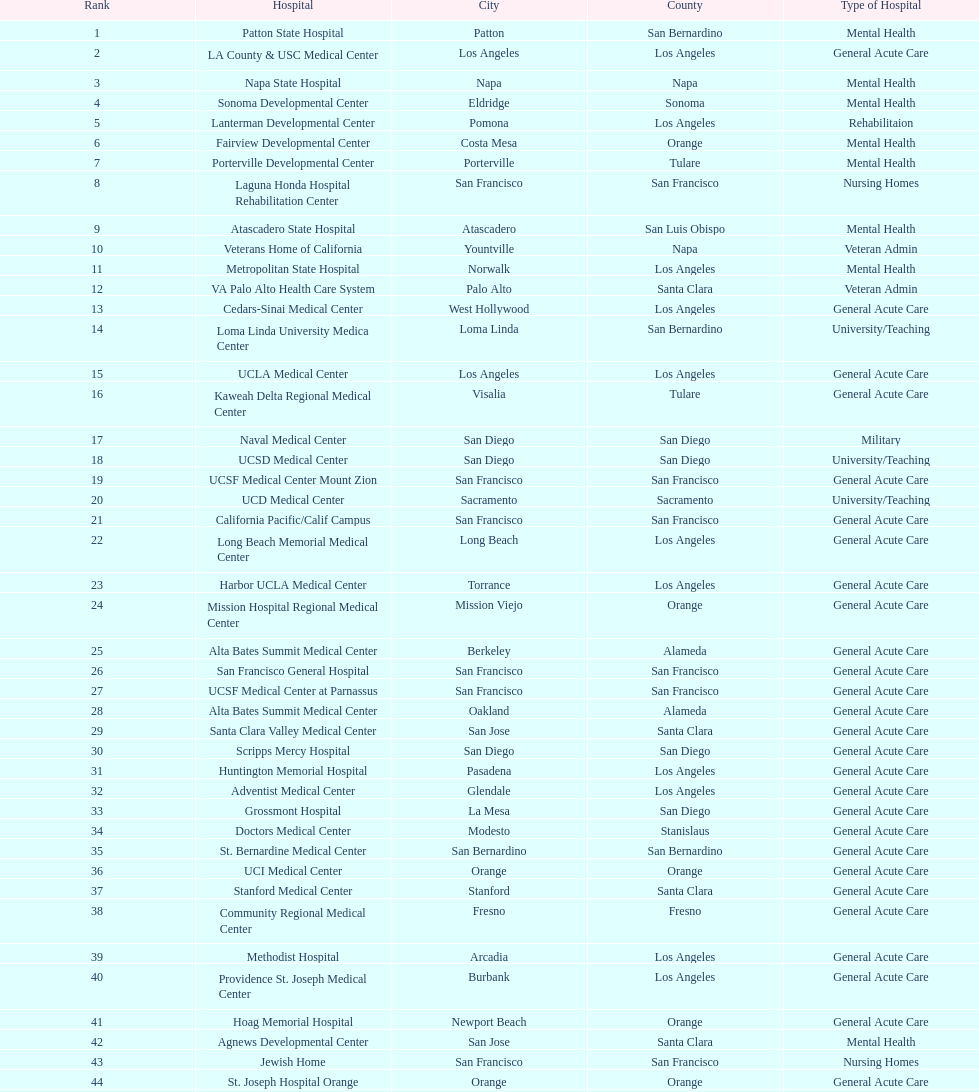How much larger (in number of beds) was the largest hospital in california than the 50th largest? 1071. 